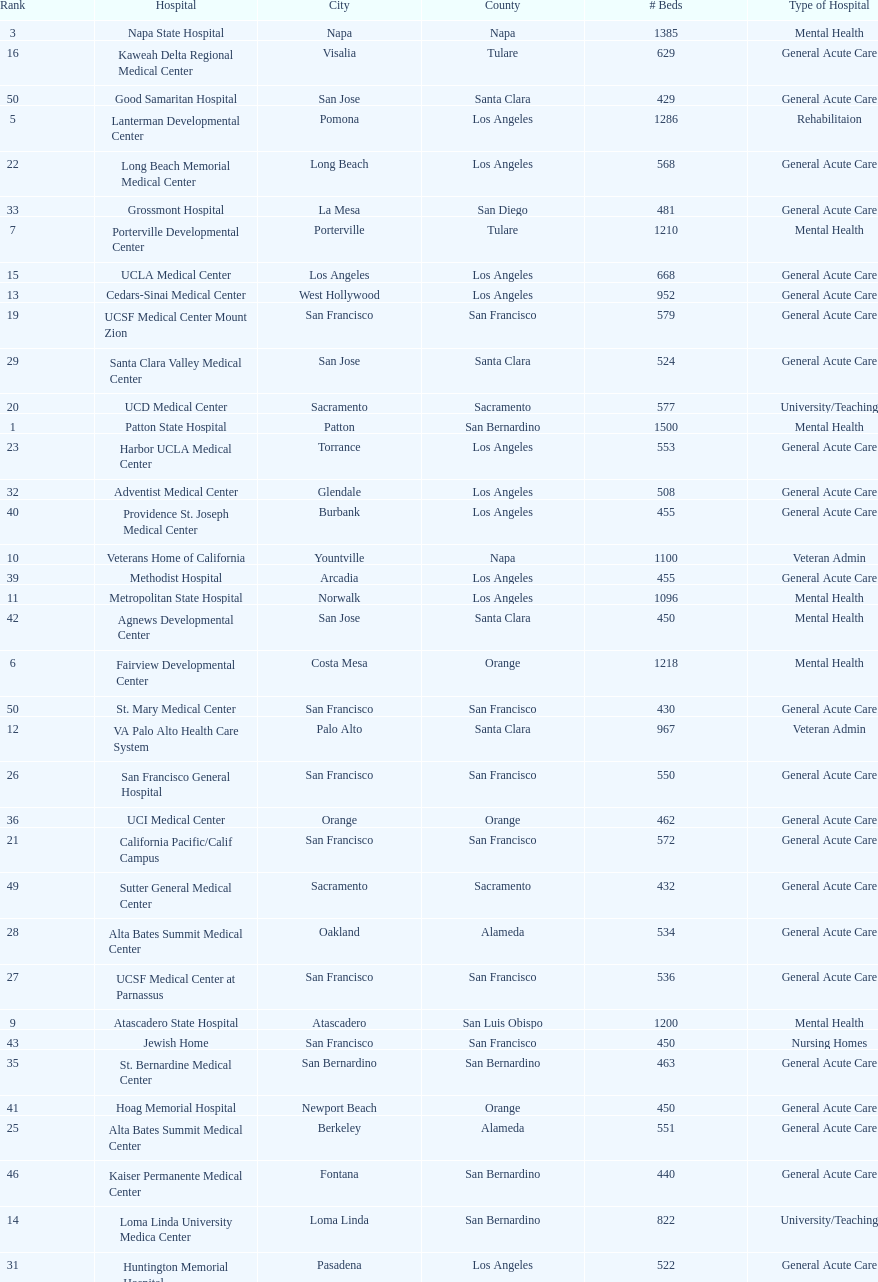How many more general acute care hospitals are there in california than rehabilitation hospitals? 33. 